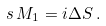<formula> <loc_0><loc_0><loc_500><loc_500>s \, M _ { 1 } = i \Delta S \, .</formula> 